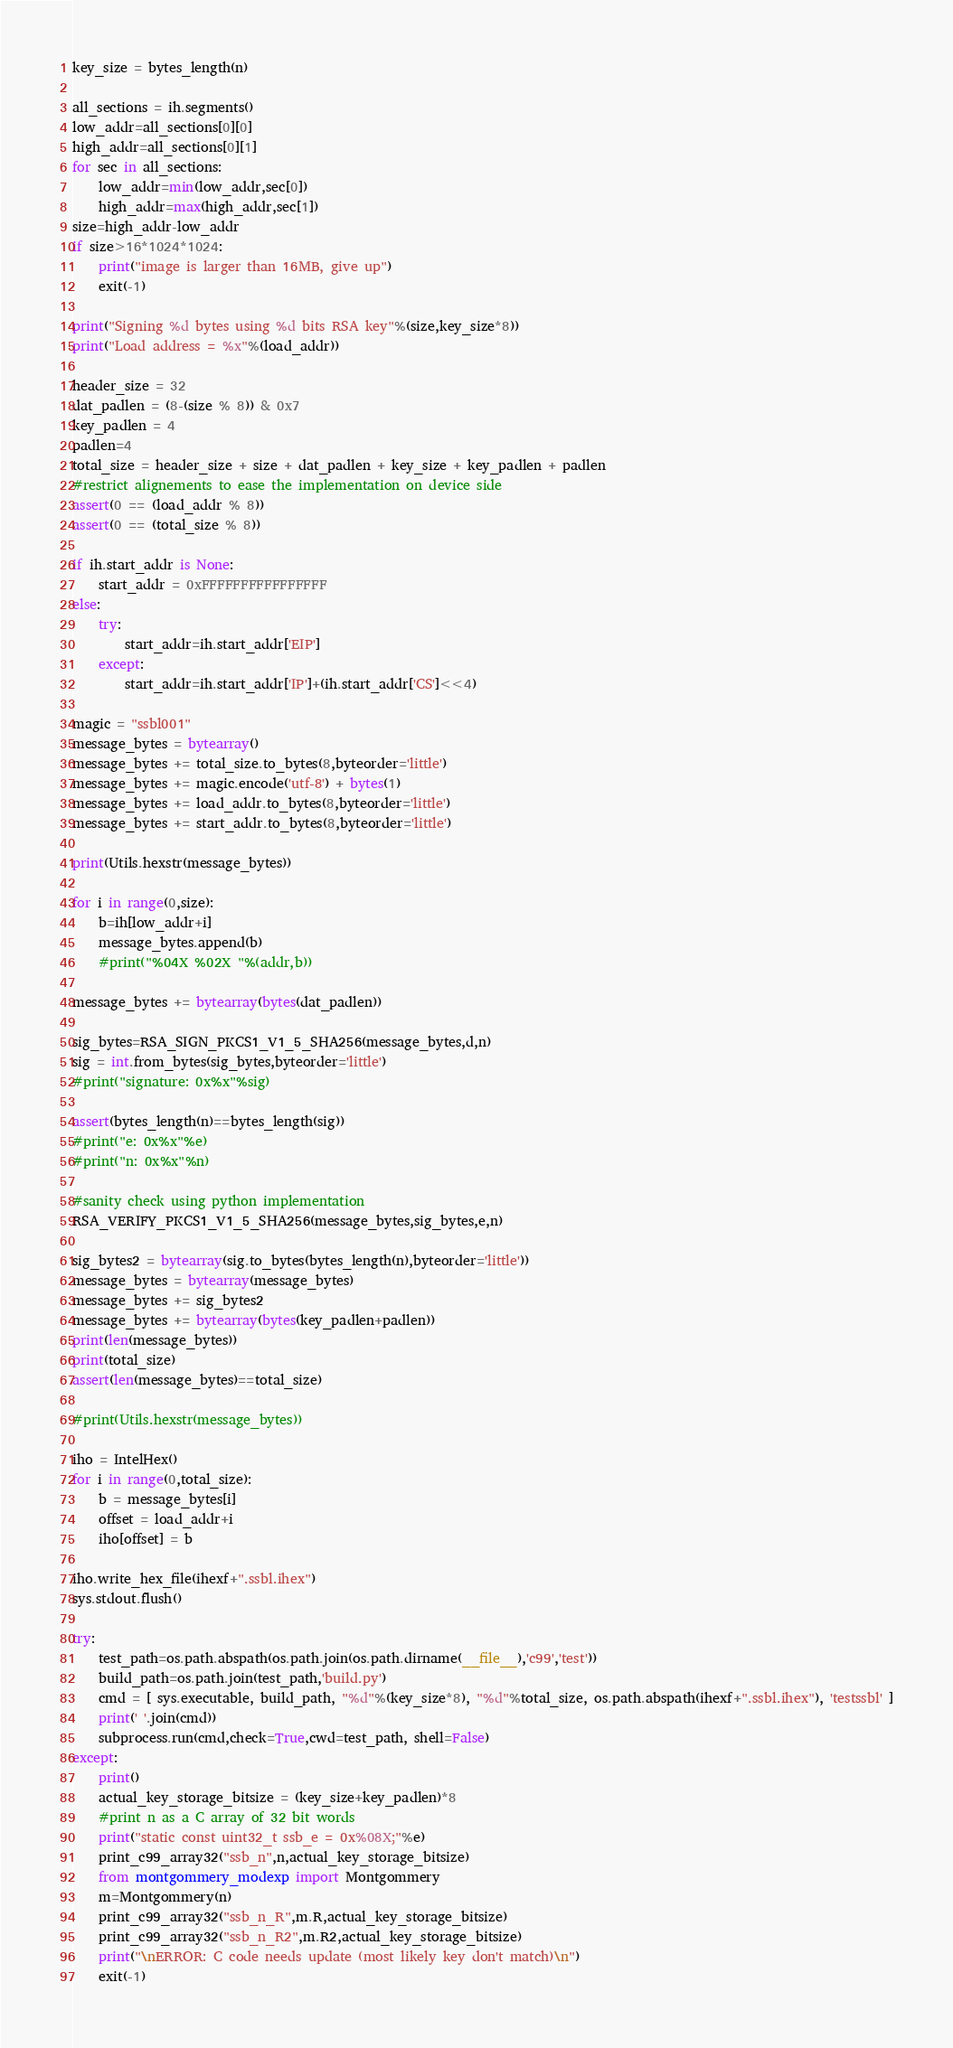Convert code to text. <code><loc_0><loc_0><loc_500><loc_500><_Python_>key_size = bytes_length(n)

all_sections = ih.segments()
low_addr=all_sections[0][0]
high_addr=all_sections[0][1]
for sec in all_sections:
    low_addr=min(low_addr,sec[0])
    high_addr=max(high_addr,sec[1])
size=high_addr-low_addr
if size>16*1024*1024:
    print("image is larger than 16MB, give up")
    exit(-1)

print("Signing %d bytes using %d bits RSA key"%(size,key_size*8))
print("Load address = %x"%(load_addr))

header_size = 32
dat_padlen = (8-(size % 8)) & 0x7
key_padlen = 4
padlen=4
total_size = header_size + size + dat_padlen + key_size + key_padlen + padlen
#restrict alignements to ease the implementation on device side
assert(0 == (load_addr % 8))
assert(0 == (total_size % 8))

if ih.start_addr is None:
    start_addr = 0xFFFFFFFFFFFFFFFF
else:
    try:
        start_addr=ih.start_addr['EIP']
    except:
        start_addr=ih.start_addr['IP']+(ih.start_addr['CS']<<4)

magic = "ssbl001"
message_bytes = bytearray()
message_bytes += total_size.to_bytes(8,byteorder='little')
message_bytes += magic.encode('utf-8') + bytes(1)
message_bytes += load_addr.to_bytes(8,byteorder='little')
message_bytes += start_addr.to_bytes(8,byteorder='little')

print(Utils.hexstr(message_bytes))

for i in range(0,size):
    b=ih[low_addr+i]
    message_bytes.append(b)
    #print("%04X %02X "%(addr,b))

message_bytes += bytearray(bytes(dat_padlen))

sig_bytes=RSA_SIGN_PKCS1_V1_5_SHA256(message_bytes,d,n)
sig = int.from_bytes(sig_bytes,byteorder='little')
#print("signature: 0x%x"%sig)

assert(bytes_length(n)==bytes_length(sig))
#print("e: 0x%x"%e)
#print("n: 0x%x"%n)

#sanity check using python implementation
RSA_VERIFY_PKCS1_V1_5_SHA256(message_bytes,sig_bytes,e,n)

sig_bytes2 = bytearray(sig.to_bytes(bytes_length(n),byteorder='little'))
message_bytes = bytearray(message_bytes)
message_bytes += sig_bytes2
message_bytes += bytearray(bytes(key_padlen+padlen))
print(len(message_bytes))
print(total_size)
assert(len(message_bytes)==total_size)

#print(Utils.hexstr(message_bytes))

iho = IntelHex()
for i in range(0,total_size):
    b = message_bytes[i]
    offset = load_addr+i
    iho[offset] = b

iho.write_hex_file(ihexf+".ssbl.ihex")
sys.stdout.flush()

try:
    test_path=os.path.abspath(os.path.join(os.path.dirname(__file__),'c99','test'))
    build_path=os.path.join(test_path,'build.py')
    cmd = [ sys.executable, build_path, "%d"%(key_size*8), "%d"%total_size, os.path.abspath(ihexf+".ssbl.ihex"), 'testssbl' ]
    print(' '.join(cmd))
    subprocess.run(cmd,check=True,cwd=test_path, shell=False)
except:
    print()
    actual_key_storage_bitsize = (key_size+key_padlen)*8
    #print n as a C array of 32 bit words
    print("static const uint32_t ssb_e = 0x%08X;"%e)
    print_c99_array32("ssb_n",n,actual_key_storage_bitsize)
    from montgommery_modexp import Montgommery
    m=Montgommery(n)
    print_c99_array32("ssb_n_R",m.R,actual_key_storage_bitsize)
    print_c99_array32("ssb_n_R2",m.R2,actual_key_storage_bitsize)
    print("\nERROR: C code needs update (most likely key don't match)\n")
    exit(-1)
</code> 